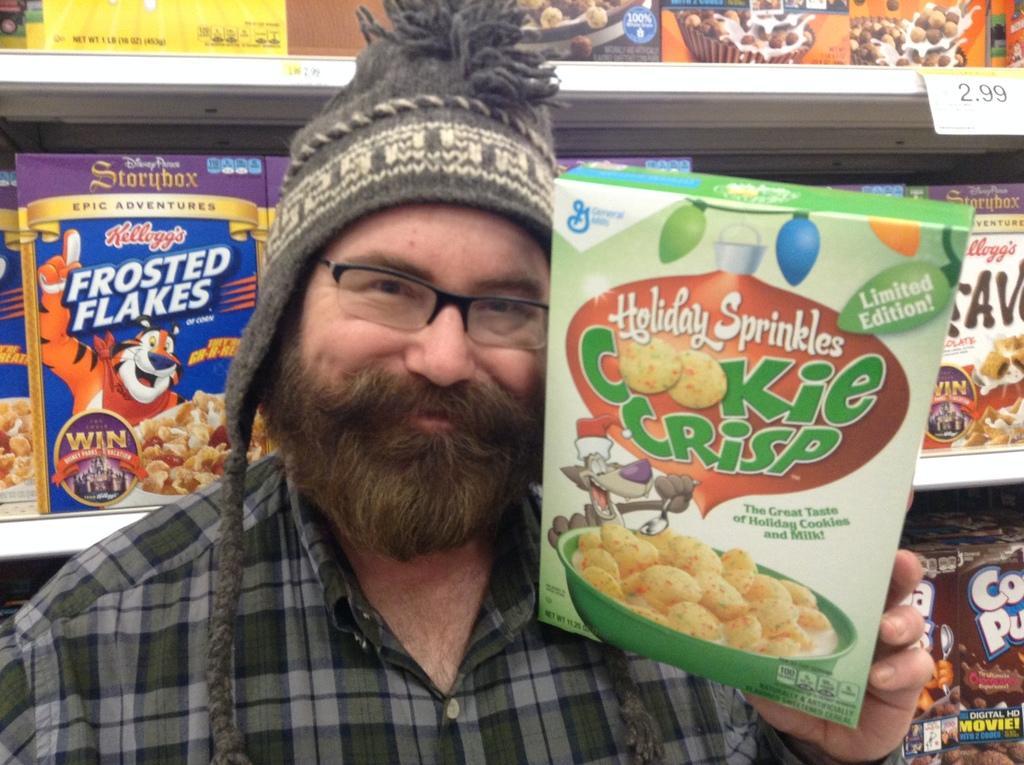How would you summarize this image in a sentence or two? In this image we can see a person wearing specs and cap. He is holding a packet. In the background there are racks with packets. On the packets there are names and some images. 